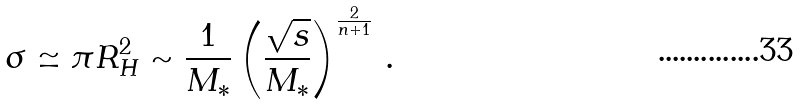<formula> <loc_0><loc_0><loc_500><loc_500>\sigma \simeq \pi R _ { H } ^ { 2 } \sim \frac { 1 } { M _ { * } } \left ( \frac { \sqrt { s } } { M _ { * } } \right ) ^ { \frac { 2 } { n + 1 } } \, .</formula> 